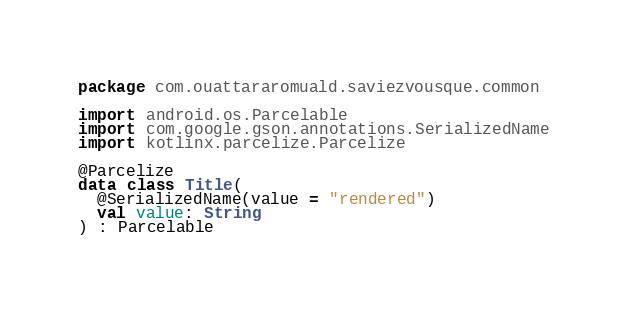<code> <loc_0><loc_0><loc_500><loc_500><_Kotlin_>package com.ouattararomuald.saviezvousque.common

import android.os.Parcelable
import com.google.gson.annotations.SerializedName
import kotlinx.parcelize.Parcelize

@Parcelize
data class Title(
  @SerializedName(value = "rendered")
  val value: String
) : Parcelable
</code> 